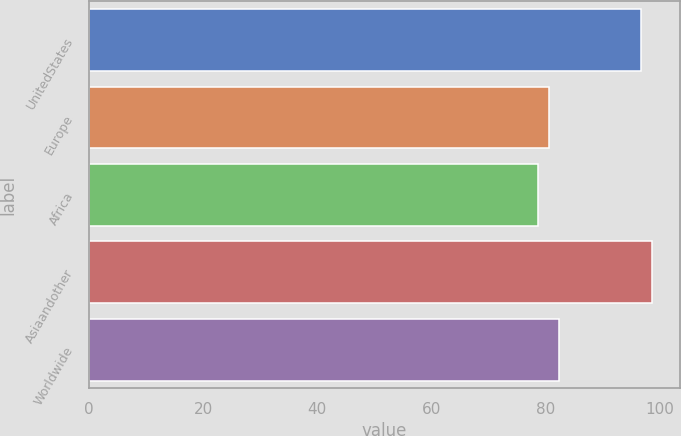Convert chart. <chart><loc_0><loc_0><loc_500><loc_500><bar_chart><fcel>UnitedStates<fcel>Europe<fcel>Africa<fcel>Asiaandother<fcel>Worldwide<nl><fcel>96.82<fcel>80.55<fcel>78.72<fcel>98.65<fcel>82.38<nl></chart> 